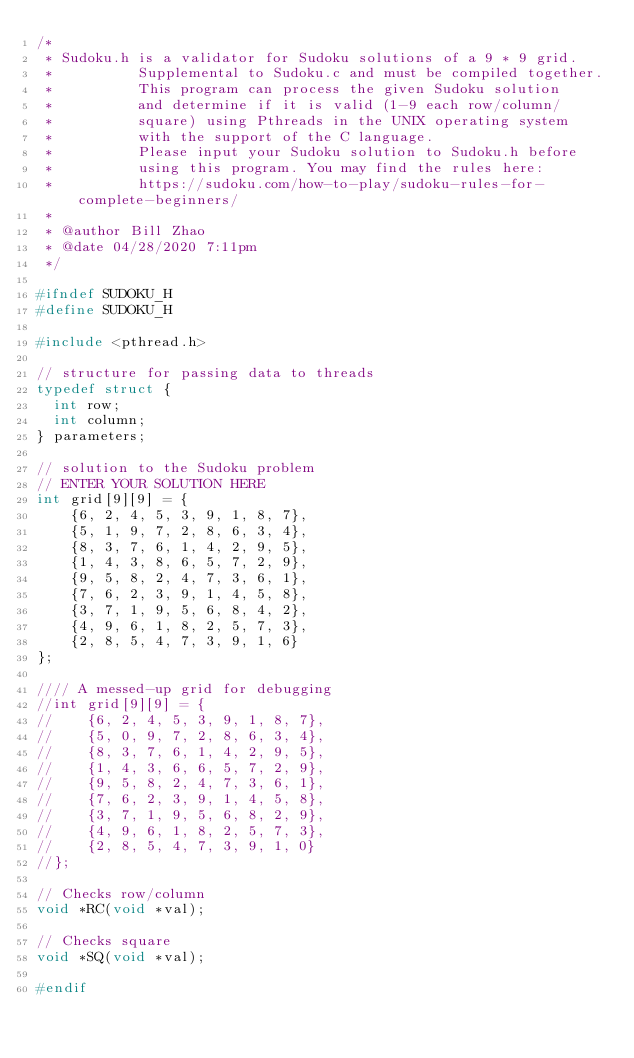<code> <loc_0><loc_0><loc_500><loc_500><_C_>/*
 * Sudoku.h is a validator for Sudoku solutions of a 9 * 9 grid.
 *          Supplemental to Sudoku.c and must be compiled together.
 *          This program can process the given Sudoku solution
 *          and determine if it is valid (1-9 each row/column/
 *          square) using Pthreads in the UNIX operating system
 *          with the support of the C language.
 *          Please input your Sudoku solution to Sudoku.h before
 *          using this program. You may find the rules here:
 *          https://sudoku.com/how-to-play/sudoku-rules-for-complete-beginners/
 * 
 * @author Bill Zhao
 * @date 04/28/2020 7:11pm
 */

#ifndef SUDOKU_H
#define SUDOKU_H

#include <pthread.h>

// structure for passing data to threads
typedef struct {
  int row;
  int column;
} parameters;

// solution to the Sudoku problem
// ENTER YOUR SOLUTION HERE
int grid[9][9] = {
    {6, 2, 4, 5, 3, 9, 1, 8, 7},
    {5, 1, 9, 7, 2, 8, 6, 3, 4},
    {8, 3, 7, 6, 1, 4, 2, 9, 5},
    {1, 4, 3, 8, 6, 5, 7, 2, 9},
    {9, 5, 8, 2, 4, 7, 3, 6, 1},
    {7, 6, 2, 3, 9, 1, 4, 5, 8},
    {3, 7, 1, 9, 5, 6, 8, 4, 2},
    {4, 9, 6, 1, 8, 2, 5, 7, 3},
    {2, 8, 5, 4, 7, 3, 9, 1, 6}
};

//// A messed-up grid for debugging
//int grid[9][9] = {
//    {6, 2, 4, 5, 3, 9, 1, 8, 7},
//    {5, 0, 9, 7, 2, 8, 6, 3, 4},
//    {8, 3, 7, 6, 1, 4, 2, 9, 5},
//    {1, 4, 3, 6, 6, 5, 7, 2, 9},
//    {9, 5, 8, 2, 4, 7, 3, 6, 1},
//    {7, 6, 2, 3, 9, 1, 4, 5, 8},
//    {3, 7, 1, 9, 5, 6, 8, 2, 9},
//    {4, 9, 6, 1, 8, 2, 5, 7, 3},
//    {2, 8, 5, 4, 7, 3, 9, 1, 0}
//};

// Checks row/column
void *RC(void *val);

// Checks square
void *SQ(void *val);

#endif
</code> 